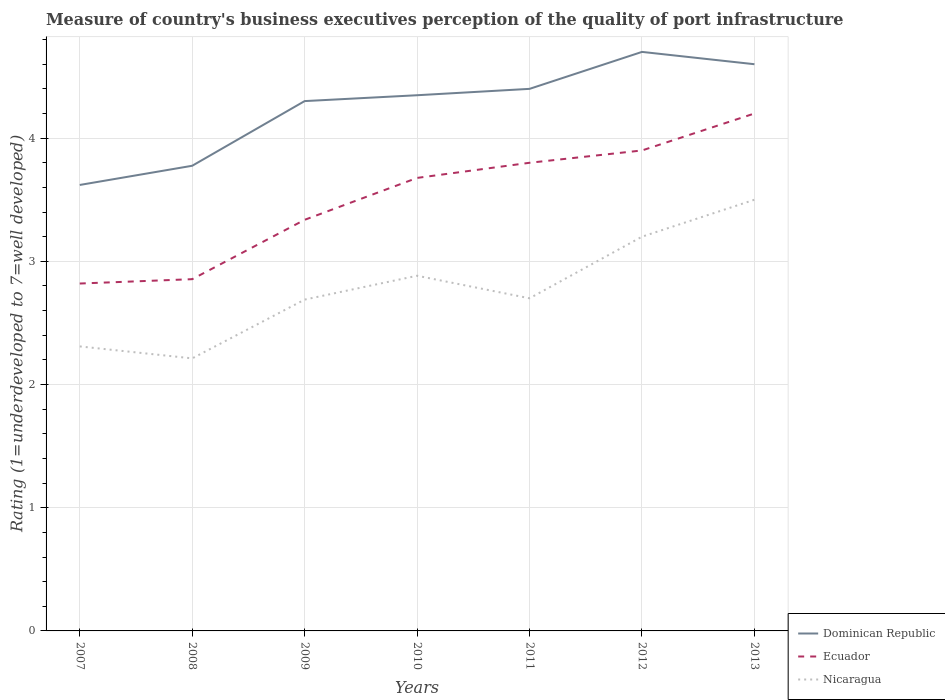How many different coloured lines are there?
Offer a terse response. 3. Does the line corresponding to Nicaragua intersect with the line corresponding to Dominican Republic?
Provide a short and direct response. No. Is the number of lines equal to the number of legend labels?
Provide a short and direct response. Yes. Across all years, what is the maximum ratings of the quality of port infrastructure in Ecuador?
Offer a very short reply. 2.82. In which year was the ratings of the quality of port infrastructure in Nicaragua maximum?
Your answer should be compact. 2008. What is the total ratings of the quality of port infrastructure in Ecuador in the graph?
Offer a terse response. -1.08. What is the difference between the highest and the second highest ratings of the quality of port infrastructure in Nicaragua?
Provide a succinct answer. 1.29. What is the difference between the highest and the lowest ratings of the quality of port infrastructure in Ecuador?
Offer a terse response. 4. Is the ratings of the quality of port infrastructure in Nicaragua strictly greater than the ratings of the quality of port infrastructure in Ecuador over the years?
Your response must be concise. Yes. How many lines are there?
Your answer should be compact. 3. How many years are there in the graph?
Keep it short and to the point. 7. What is the difference between two consecutive major ticks on the Y-axis?
Keep it short and to the point. 1. Are the values on the major ticks of Y-axis written in scientific E-notation?
Provide a succinct answer. No. How many legend labels are there?
Offer a terse response. 3. What is the title of the graph?
Your response must be concise. Measure of country's business executives perception of the quality of port infrastructure. What is the label or title of the Y-axis?
Provide a succinct answer. Rating (1=underdeveloped to 7=well developed). What is the Rating (1=underdeveloped to 7=well developed) of Dominican Republic in 2007?
Make the answer very short. 3.62. What is the Rating (1=underdeveloped to 7=well developed) of Ecuador in 2007?
Provide a succinct answer. 2.82. What is the Rating (1=underdeveloped to 7=well developed) in Nicaragua in 2007?
Your answer should be compact. 2.31. What is the Rating (1=underdeveloped to 7=well developed) of Dominican Republic in 2008?
Provide a succinct answer. 3.78. What is the Rating (1=underdeveloped to 7=well developed) in Ecuador in 2008?
Provide a succinct answer. 2.86. What is the Rating (1=underdeveloped to 7=well developed) in Nicaragua in 2008?
Your answer should be very brief. 2.21. What is the Rating (1=underdeveloped to 7=well developed) in Dominican Republic in 2009?
Keep it short and to the point. 4.3. What is the Rating (1=underdeveloped to 7=well developed) in Ecuador in 2009?
Keep it short and to the point. 3.34. What is the Rating (1=underdeveloped to 7=well developed) in Nicaragua in 2009?
Give a very brief answer. 2.69. What is the Rating (1=underdeveloped to 7=well developed) in Dominican Republic in 2010?
Your response must be concise. 4.35. What is the Rating (1=underdeveloped to 7=well developed) of Ecuador in 2010?
Provide a succinct answer. 3.68. What is the Rating (1=underdeveloped to 7=well developed) of Nicaragua in 2010?
Offer a terse response. 2.88. What is the Rating (1=underdeveloped to 7=well developed) of Nicaragua in 2011?
Ensure brevity in your answer.  2.7. What is the Rating (1=underdeveloped to 7=well developed) of Ecuador in 2012?
Offer a very short reply. 3.9. What is the Rating (1=underdeveloped to 7=well developed) in Dominican Republic in 2013?
Your answer should be very brief. 4.6. What is the Rating (1=underdeveloped to 7=well developed) of Nicaragua in 2013?
Your answer should be very brief. 3.5. Across all years, what is the maximum Rating (1=underdeveloped to 7=well developed) in Nicaragua?
Ensure brevity in your answer.  3.5. Across all years, what is the minimum Rating (1=underdeveloped to 7=well developed) of Dominican Republic?
Offer a terse response. 3.62. Across all years, what is the minimum Rating (1=underdeveloped to 7=well developed) of Ecuador?
Your response must be concise. 2.82. Across all years, what is the minimum Rating (1=underdeveloped to 7=well developed) in Nicaragua?
Ensure brevity in your answer.  2.21. What is the total Rating (1=underdeveloped to 7=well developed) in Dominican Republic in the graph?
Your answer should be very brief. 29.74. What is the total Rating (1=underdeveloped to 7=well developed) in Ecuador in the graph?
Give a very brief answer. 24.59. What is the total Rating (1=underdeveloped to 7=well developed) of Nicaragua in the graph?
Give a very brief answer. 19.49. What is the difference between the Rating (1=underdeveloped to 7=well developed) in Dominican Republic in 2007 and that in 2008?
Provide a succinct answer. -0.16. What is the difference between the Rating (1=underdeveloped to 7=well developed) in Ecuador in 2007 and that in 2008?
Your answer should be compact. -0.04. What is the difference between the Rating (1=underdeveloped to 7=well developed) of Nicaragua in 2007 and that in 2008?
Provide a short and direct response. 0.1. What is the difference between the Rating (1=underdeveloped to 7=well developed) of Dominican Republic in 2007 and that in 2009?
Offer a terse response. -0.68. What is the difference between the Rating (1=underdeveloped to 7=well developed) of Ecuador in 2007 and that in 2009?
Your response must be concise. -0.52. What is the difference between the Rating (1=underdeveloped to 7=well developed) of Nicaragua in 2007 and that in 2009?
Keep it short and to the point. -0.38. What is the difference between the Rating (1=underdeveloped to 7=well developed) in Dominican Republic in 2007 and that in 2010?
Provide a short and direct response. -0.73. What is the difference between the Rating (1=underdeveloped to 7=well developed) of Ecuador in 2007 and that in 2010?
Keep it short and to the point. -0.86. What is the difference between the Rating (1=underdeveloped to 7=well developed) in Nicaragua in 2007 and that in 2010?
Your answer should be very brief. -0.57. What is the difference between the Rating (1=underdeveloped to 7=well developed) of Dominican Republic in 2007 and that in 2011?
Make the answer very short. -0.78. What is the difference between the Rating (1=underdeveloped to 7=well developed) of Ecuador in 2007 and that in 2011?
Keep it short and to the point. -0.98. What is the difference between the Rating (1=underdeveloped to 7=well developed) in Nicaragua in 2007 and that in 2011?
Provide a short and direct response. -0.39. What is the difference between the Rating (1=underdeveloped to 7=well developed) in Dominican Republic in 2007 and that in 2012?
Keep it short and to the point. -1.08. What is the difference between the Rating (1=underdeveloped to 7=well developed) of Ecuador in 2007 and that in 2012?
Your answer should be very brief. -1.08. What is the difference between the Rating (1=underdeveloped to 7=well developed) of Nicaragua in 2007 and that in 2012?
Your answer should be compact. -0.89. What is the difference between the Rating (1=underdeveloped to 7=well developed) of Dominican Republic in 2007 and that in 2013?
Make the answer very short. -0.98. What is the difference between the Rating (1=underdeveloped to 7=well developed) in Ecuador in 2007 and that in 2013?
Your answer should be compact. -1.38. What is the difference between the Rating (1=underdeveloped to 7=well developed) of Nicaragua in 2007 and that in 2013?
Your response must be concise. -1.19. What is the difference between the Rating (1=underdeveloped to 7=well developed) in Dominican Republic in 2008 and that in 2009?
Keep it short and to the point. -0.53. What is the difference between the Rating (1=underdeveloped to 7=well developed) of Ecuador in 2008 and that in 2009?
Your answer should be compact. -0.48. What is the difference between the Rating (1=underdeveloped to 7=well developed) of Nicaragua in 2008 and that in 2009?
Keep it short and to the point. -0.48. What is the difference between the Rating (1=underdeveloped to 7=well developed) in Dominican Republic in 2008 and that in 2010?
Your response must be concise. -0.57. What is the difference between the Rating (1=underdeveloped to 7=well developed) of Ecuador in 2008 and that in 2010?
Your answer should be compact. -0.82. What is the difference between the Rating (1=underdeveloped to 7=well developed) of Nicaragua in 2008 and that in 2010?
Keep it short and to the point. -0.67. What is the difference between the Rating (1=underdeveloped to 7=well developed) of Dominican Republic in 2008 and that in 2011?
Provide a succinct answer. -0.62. What is the difference between the Rating (1=underdeveloped to 7=well developed) in Ecuador in 2008 and that in 2011?
Your response must be concise. -0.94. What is the difference between the Rating (1=underdeveloped to 7=well developed) of Nicaragua in 2008 and that in 2011?
Your response must be concise. -0.49. What is the difference between the Rating (1=underdeveloped to 7=well developed) in Dominican Republic in 2008 and that in 2012?
Ensure brevity in your answer.  -0.92. What is the difference between the Rating (1=underdeveloped to 7=well developed) of Ecuador in 2008 and that in 2012?
Your response must be concise. -1.04. What is the difference between the Rating (1=underdeveloped to 7=well developed) in Nicaragua in 2008 and that in 2012?
Offer a terse response. -0.99. What is the difference between the Rating (1=underdeveloped to 7=well developed) of Dominican Republic in 2008 and that in 2013?
Your response must be concise. -0.82. What is the difference between the Rating (1=underdeveloped to 7=well developed) of Ecuador in 2008 and that in 2013?
Offer a terse response. -1.34. What is the difference between the Rating (1=underdeveloped to 7=well developed) in Nicaragua in 2008 and that in 2013?
Offer a very short reply. -1.29. What is the difference between the Rating (1=underdeveloped to 7=well developed) in Dominican Republic in 2009 and that in 2010?
Provide a short and direct response. -0.05. What is the difference between the Rating (1=underdeveloped to 7=well developed) of Ecuador in 2009 and that in 2010?
Make the answer very short. -0.34. What is the difference between the Rating (1=underdeveloped to 7=well developed) in Nicaragua in 2009 and that in 2010?
Provide a short and direct response. -0.19. What is the difference between the Rating (1=underdeveloped to 7=well developed) in Dominican Republic in 2009 and that in 2011?
Your answer should be very brief. -0.1. What is the difference between the Rating (1=underdeveloped to 7=well developed) in Ecuador in 2009 and that in 2011?
Your response must be concise. -0.46. What is the difference between the Rating (1=underdeveloped to 7=well developed) of Nicaragua in 2009 and that in 2011?
Provide a succinct answer. -0.01. What is the difference between the Rating (1=underdeveloped to 7=well developed) of Dominican Republic in 2009 and that in 2012?
Make the answer very short. -0.4. What is the difference between the Rating (1=underdeveloped to 7=well developed) in Ecuador in 2009 and that in 2012?
Give a very brief answer. -0.56. What is the difference between the Rating (1=underdeveloped to 7=well developed) of Nicaragua in 2009 and that in 2012?
Provide a short and direct response. -0.51. What is the difference between the Rating (1=underdeveloped to 7=well developed) in Dominican Republic in 2009 and that in 2013?
Ensure brevity in your answer.  -0.3. What is the difference between the Rating (1=underdeveloped to 7=well developed) in Ecuador in 2009 and that in 2013?
Keep it short and to the point. -0.86. What is the difference between the Rating (1=underdeveloped to 7=well developed) of Nicaragua in 2009 and that in 2013?
Keep it short and to the point. -0.81. What is the difference between the Rating (1=underdeveloped to 7=well developed) of Dominican Republic in 2010 and that in 2011?
Your answer should be very brief. -0.05. What is the difference between the Rating (1=underdeveloped to 7=well developed) of Ecuador in 2010 and that in 2011?
Your answer should be compact. -0.12. What is the difference between the Rating (1=underdeveloped to 7=well developed) of Nicaragua in 2010 and that in 2011?
Provide a succinct answer. 0.18. What is the difference between the Rating (1=underdeveloped to 7=well developed) in Dominican Republic in 2010 and that in 2012?
Your answer should be very brief. -0.35. What is the difference between the Rating (1=underdeveloped to 7=well developed) in Ecuador in 2010 and that in 2012?
Your response must be concise. -0.22. What is the difference between the Rating (1=underdeveloped to 7=well developed) of Nicaragua in 2010 and that in 2012?
Ensure brevity in your answer.  -0.32. What is the difference between the Rating (1=underdeveloped to 7=well developed) in Dominican Republic in 2010 and that in 2013?
Your answer should be very brief. -0.25. What is the difference between the Rating (1=underdeveloped to 7=well developed) of Ecuador in 2010 and that in 2013?
Your answer should be very brief. -0.52. What is the difference between the Rating (1=underdeveloped to 7=well developed) in Nicaragua in 2010 and that in 2013?
Make the answer very short. -0.62. What is the difference between the Rating (1=underdeveloped to 7=well developed) in Dominican Republic in 2011 and that in 2013?
Provide a succinct answer. -0.2. What is the difference between the Rating (1=underdeveloped to 7=well developed) in Ecuador in 2011 and that in 2013?
Make the answer very short. -0.4. What is the difference between the Rating (1=underdeveloped to 7=well developed) in Dominican Republic in 2012 and that in 2013?
Offer a terse response. 0.1. What is the difference between the Rating (1=underdeveloped to 7=well developed) in Dominican Republic in 2007 and the Rating (1=underdeveloped to 7=well developed) in Ecuador in 2008?
Your answer should be compact. 0.76. What is the difference between the Rating (1=underdeveloped to 7=well developed) in Dominican Republic in 2007 and the Rating (1=underdeveloped to 7=well developed) in Nicaragua in 2008?
Offer a terse response. 1.41. What is the difference between the Rating (1=underdeveloped to 7=well developed) of Ecuador in 2007 and the Rating (1=underdeveloped to 7=well developed) of Nicaragua in 2008?
Give a very brief answer. 0.61. What is the difference between the Rating (1=underdeveloped to 7=well developed) in Dominican Republic in 2007 and the Rating (1=underdeveloped to 7=well developed) in Ecuador in 2009?
Make the answer very short. 0.28. What is the difference between the Rating (1=underdeveloped to 7=well developed) in Dominican Republic in 2007 and the Rating (1=underdeveloped to 7=well developed) in Nicaragua in 2009?
Offer a terse response. 0.93. What is the difference between the Rating (1=underdeveloped to 7=well developed) of Ecuador in 2007 and the Rating (1=underdeveloped to 7=well developed) of Nicaragua in 2009?
Ensure brevity in your answer.  0.13. What is the difference between the Rating (1=underdeveloped to 7=well developed) of Dominican Republic in 2007 and the Rating (1=underdeveloped to 7=well developed) of Ecuador in 2010?
Your response must be concise. -0.06. What is the difference between the Rating (1=underdeveloped to 7=well developed) in Dominican Republic in 2007 and the Rating (1=underdeveloped to 7=well developed) in Nicaragua in 2010?
Ensure brevity in your answer.  0.74. What is the difference between the Rating (1=underdeveloped to 7=well developed) of Ecuador in 2007 and the Rating (1=underdeveloped to 7=well developed) of Nicaragua in 2010?
Your answer should be very brief. -0.06. What is the difference between the Rating (1=underdeveloped to 7=well developed) of Dominican Republic in 2007 and the Rating (1=underdeveloped to 7=well developed) of Ecuador in 2011?
Provide a succinct answer. -0.18. What is the difference between the Rating (1=underdeveloped to 7=well developed) of Dominican Republic in 2007 and the Rating (1=underdeveloped to 7=well developed) of Nicaragua in 2011?
Make the answer very short. 0.92. What is the difference between the Rating (1=underdeveloped to 7=well developed) of Ecuador in 2007 and the Rating (1=underdeveloped to 7=well developed) of Nicaragua in 2011?
Your answer should be very brief. 0.12. What is the difference between the Rating (1=underdeveloped to 7=well developed) in Dominican Republic in 2007 and the Rating (1=underdeveloped to 7=well developed) in Ecuador in 2012?
Ensure brevity in your answer.  -0.28. What is the difference between the Rating (1=underdeveloped to 7=well developed) in Dominican Republic in 2007 and the Rating (1=underdeveloped to 7=well developed) in Nicaragua in 2012?
Offer a very short reply. 0.42. What is the difference between the Rating (1=underdeveloped to 7=well developed) in Ecuador in 2007 and the Rating (1=underdeveloped to 7=well developed) in Nicaragua in 2012?
Offer a terse response. -0.38. What is the difference between the Rating (1=underdeveloped to 7=well developed) in Dominican Republic in 2007 and the Rating (1=underdeveloped to 7=well developed) in Ecuador in 2013?
Provide a short and direct response. -0.58. What is the difference between the Rating (1=underdeveloped to 7=well developed) in Dominican Republic in 2007 and the Rating (1=underdeveloped to 7=well developed) in Nicaragua in 2013?
Your answer should be very brief. 0.12. What is the difference between the Rating (1=underdeveloped to 7=well developed) in Ecuador in 2007 and the Rating (1=underdeveloped to 7=well developed) in Nicaragua in 2013?
Your answer should be very brief. -0.68. What is the difference between the Rating (1=underdeveloped to 7=well developed) of Dominican Republic in 2008 and the Rating (1=underdeveloped to 7=well developed) of Ecuador in 2009?
Your response must be concise. 0.44. What is the difference between the Rating (1=underdeveloped to 7=well developed) of Dominican Republic in 2008 and the Rating (1=underdeveloped to 7=well developed) of Nicaragua in 2009?
Ensure brevity in your answer.  1.09. What is the difference between the Rating (1=underdeveloped to 7=well developed) in Ecuador in 2008 and the Rating (1=underdeveloped to 7=well developed) in Nicaragua in 2009?
Provide a short and direct response. 0.17. What is the difference between the Rating (1=underdeveloped to 7=well developed) in Dominican Republic in 2008 and the Rating (1=underdeveloped to 7=well developed) in Ecuador in 2010?
Your answer should be very brief. 0.1. What is the difference between the Rating (1=underdeveloped to 7=well developed) of Dominican Republic in 2008 and the Rating (1=underdeveloped to 7=well developed) of Nicaragua in 2010?
Keep it short and to the point. 0.89. What is the difference between the Rating (1=underdeveloped to 7=well developed) of Ecuador in 2008 and the Rating (1=underdeveloped to 7=well developed) of Nicaragua in 2010?
Offer a very short reply. -0.03. What is the difference between the Rating (1=underdeveloped to 7=well developed) in Dominican Republic in 2008 and the Rating (1=underdeveloped to 7=well developed) in Ecuador in 2011?
Your answer should be very brief. -0.02. What is the difference between the Rating (1=underdeveloped to 7=well developed) of Dominican Republic in 2008 and the Rating (1=underdeveloped to 7=well developed) of Nicaragua in 2011?
Provide a succinct answer. 1.08. What is the difference between the Rating (1=underdeveloped to 7=well developed) in Ecuador in 2008 and the Rating (1=underdeveloped to 7=well developed) in Nicaragua in 2011?
Your answer should be very brief. 0.16. What is the difference between the Rating (1=underdeveloped to 7=well developed) of Dominican Republic in 2008 and the Rating (1=underdeveloped to 7=well developed) of Ecuador in 2012?
Keep it short and to the point. -0.12. What is the difference between the Rating (1=underdeveloped to 7=well developed) in Dominican Republic in 2008 and the Rating (1=underdeveloped to 7=well developed) in Nicaragua in 2012?
Ensure brevity in your answer.  0.58. What is the difference between the Rating (1=underdeveloped to 7=well developed) in Ecuador in 2008 and the Rating (1=underdeveloped to 7=well developed) in Nicaragua in 2012?
Your response must be concise. -0.34. What is the difference between the Rating (1=underdeveloped to 7=well developed) of Dominican Republic in 2008 and the Rating (1=underdeveloped to 7=well developed) of Ecuador in 2013?
Your response must be concise. -0.42. What is the difference between the Rating (1=underdeveloped to 7=well developed) of Dominican Republic in 2008 and the Rating (1=underdeveloped to 7=well developed) of Nicaragua in 2013?
Provide a short and direct response. 0.28. What is the difference between the Rating (1=underdeveloped to 7=well developed) in Ecuador in 2008 and the Rating (1=underdeveloped to 7=well developed) in Nicaragua in 2013?
Provide a short and direct response. -0.64. What is the difference between the Rating (1=underdeveloped to 7=well developed) in Dominican Republic in 2009 and the Rating (1=underdeveloped to 7=well developed) in Ecuador in 2010?
Keep it short and to the point. 0.62. What is the difference between the Rating (1=underdeveloped to 7=well developed) in Dominican Republic in 2009 and the Rating (1=underdeveloped to 7=well developed) in Nicaragua in 2010?
Offer a terse response. 1.42. What is the difference between the Rating (1=underdeveloped to 7=well developed) in Ecuador in 2009 and the Rating (1=underdeveloped to 7=well developed) in Nicaragua in 2010?
Make the answer very short. 0.45. What is the difference between the Rating (1=underdeveloped to 7=well developed) in Dominican Republic in 2009 and the Rating (1=underdeveloped to 7=well developed) in Ecuador in 2011?
Provide a succinct answer. 0.5. What is the difference between the Rating (1=underdeveloped to 7=well developed) in Dominican Republic in 2009 and the Rating (1=underdeveloped to 7=well developed) in Nicaragua in 2011?
Your response must be concise. 1.6. What is the difference between the Rating (1=underdeveloped to 7=well developed) in Ecuador in 2009 and the Rating (1=underdeveloped to 7=well developed) in Nicaragua in 2011?
Ensure brevity in your answer.  0.64. What is the difference between the Rating (1=underdeveloped to 7=well developed) of Dominican Republic in 2009 and the Rating (1=underdeveloped to 7=well developed) of Ecuador in 2012?
Your answer should be compact. 0.4. What is the difference between the Rating (1=underdeveloped to 7=well developed) of Dominican Republic in 2009 and the Rating (1=underdeveloped to 7=well developed) of Nicaragua in 2012?
Provide a short and direct response. 1.1. What is the difference between the Rating (1=underdeveloped to 7=well developed) of Ecuador in 2009 and the Rating (1=underdeveloped to 7=well developed) of Nicaragua in 2012?
Give a very brief answer. 0.14. What is the difference between the Rating (1=underdeveloped to 7=well developed) of Dominican Republic in 2009 and the Rating (1=underdeveloped to 7=well developed) of Ecuador in 2013?
Keep it short and to the point. 0.1. What is the difference between the Rating (1=underdeveloped to 7=well developed) of Dominican Republic in 2009 and the Rating (1=underdeveloped to 7=well developed) of Nicaragua in 2013?
Your answer should be very brief. 0.8. What is the difference between the Rating (1=underdeveloped to 7=well developed) in Ecuador in 2009 and the Rating (1=underdeveloped to 7=well developed) in Nicaragua in 2013?
Offer a terse response. -0.16. What is the difference between the Rating (1=underdeveloped to 7=well developed) in Dominican Republic in 2010 and the Rating (1=underdeveloped to 7=well developed) in Ecuador in 2011?
Offer a terse response. 0.55. What is the difference between the Rating (1=underdeveloped to 7=well developed) of Dominican Republic in 2010 and the Rating (1=underdeveloped to 7=well developed) of Nicaragua in 2011?
Keep it short and to the point. 1.65. What is the difference between the Rating (1=underdeveloped to 7=well developed) of Ecuador in 2010 and the Rating (1=underdeveloped to 7=well developed) of Nicaragua in 2011?
Give a very brief answer. 0.98. What is the difference between the Rating (1=underdeveloped to 7=well developed) of Dominican Republic in 2010 and the Rating (1=underdeveloped to 7=well developed) of Ecuador in 2012?
Offer a terse response. 0.45. What is the difference between the Rating (1=underdeveloped to 7=well developed) in Dominican Republic in 2010 and the Rating (1=underdeveloped to 7=well developed) in Nicaragua in 2012?
Give a very brief answer. 1.15. What is the difference between the Rating (1=underdeveloped to 7=well developed) of Ecuador in 2010 and the Rating (1=underdeveloped to 7=well developed) of Nicaragua in 2012?
Offer a terse response. 0.48. What is the difference between the Rating (1=underdeveloped to 7=well developed) of Dominican Republic in 2010 and the Rating (1=underdeveloped to 7=well developed) of Ecuador in 2013?
Provide a succinct answer. 0.15. What is the difference between the Rating (1=underdeveloped to 7=well developed) of Dominican Republic in 2010 and the Rating (1=underdeveloped to 7=well developed) of Nicaragua in 2013?
Make the answer very short. 0.85. What is the difference between the Rating (1=underdeveloped to 7=well developed) in Ecuador in 2010 and the Rating (1=underdeveloped to 7=well developed) in Nicaragua in 2013?
Keep it short and to the point. 0.18. What is the difference between the Rating (1=underdeveloped to 7=well developed) of Dominican Republic in 2011 and the Rating (1=underdeveloped to 7=well developed) of Ecuador in 2012?
Ensure brevity in your answer.  0.5. What is the difference between the Rating (1=underdeveloped to 7=well developed) in Dominican Republic in 2012 and the Rating (1=underdeveloped to 7=well developed) in Ecuador in 2013?
Offer a very short reply. 0.5. What is the difference between the Rating (1=underdeveloped to 7=well developed) of Ecuador in 2012 and the Rating (1=underdeveloped to 7=well developed) of Nicaragua in 2013?
Your answer should be compact. 0.4. What is the average Rating (1=underdeveloped to 7=well developed) in Dominican Republic per year?
Your answer should be very brief. 4.25. What is the average Rating (1=underdeveloped to 7=well developed) of Ecuador per year?
Make the answer very short. 3.51. What is the average Rating (1=underdeveloped to 7=well developed) in Nicaragua per year?
Your answer should be compact. 2.78. In the year 2007, what is the difference between the Rating (1=underdeveloped to 7=well developed) of Dominican Republic and Rating (1=underdeveloped to 7=well developed) of Ecuador?
Keep it short and to the point. 0.8. In the year 2007, what is the difference between the Rating (1=underdeveloped to 7=well developed) of Dominican Republic and Rating (1=underdeveloped to 7=well developed) of Nicaragua?
Provide a short and direct response. 1.31. In the year 2007, what is the difference between the Rating (1=underdeveloped to 7=well developed) of Ecuador and Rating (1=underdeveloped to 7=well developed) of Nicaragua?
Ensure brevity in your answer.  0.51. In the year 2008, what is the difference between the Rating (1=underdeveloped to 7=well developed) of Dominican Republic and Rating (1=underdeveloped to 7=well developed) of Ecuador?
Ensure brevity in your answer.  0.92. In the year 2008, what is the difference between the Rating (1=underdeveloped to 7=well developed) in Dominican Republic and Rating (1=underdeveloped to 7=well developed) in Nicaragua?
Offer a terse response. 1.56. In the year 2008, what is the difference between the Rating (1=underdeveloped to 7=well developed) in Ecuador and Rating (1=underdeveloped to 7=well developed) in Nicaragua?
Ensure brevity in your answer.  0.64. In the year 2009, what is the difference between the Rating (1=underdeveloped to 7=well developed) in Dominican Republic and Rating (1=underdeveloped to 7=well developed) in Ecuador?
Your answer should be very brief. 0.96. In the year 2009, what is the difference between the Rating (1=underdeveloped to 7=well developed) of Dominican Republic and Rating (1=underdeveloped to 7=well developed) of Nicaragua?
Keep it short and to the point. 1.61. In the year 2009, what is the difference between the Rating (1=underdeveloped to 7=well developed) of Ecuador and Rating (1=underdeveloped to 7=well developed) of Nicaragua?
Make the answer very short. 0.65. In the year 2010, what is the difference between the Rating (1=underdeveloped to 7=well developed) of Dominican Republic and Rating (1=underdeveloped to 7=well developed) of Ecuador?
Your response must be concise. 0.67. In the year 2010, what is the difference between the Rating (1=underdeveloped to 7=well developed) in Dominican Republic and Rating (1=underdeveloped to 7=well developed) in Nicaragua?
Ensure brevity in your answer.  1.47. In the year 2010, what is the difference between the Rating (1=underdeveloped to 7=well developed) of Ecuador and Rating (1=underdeveloped to 7=well developed) of Nicaragua?
Ensure brevity in your answer.  0.79. In the year 2011, what is the difference between the Rating (1=underdeveloped to 7=well developed) of Dominican Republic and Rating (1=underdeveloped to 7=well developed) of Ecuador?
Keep it short and to the point. 0.6. In the year 2012, what is the difference between the Rating (1=underdeveloped to 7=well developed) in Dominican Republic and Rating (1=underdeveloped to 7=well developed) in Ecuador?
Ensure brevity in your answer.  0.8. In the year 2012, what is the difference between the Rating (1=underdeveloped to 7=well developed) of Dominican Republic and Rating (1=underdeveloped to 7=well developed) of Nicaragua?
Your answer should be compact. 1.5. In the year 2012, what is the difference between the Rating (1=underdeveloped to 7=well developed) of Ecuador and Rating (1=underdeveloped to 7=well developed) of Nicaragua?
Your response must be concise. 0.7. In the year 2013, what is the difference between the Rating (1=underdeveloped to 7=well developed) in Ecuador and Rating (1=underdeveloped to 7=well developed) in Nicaragua?
Make the answer very short. 0.7. What is the ratio of the Rating (1=underdeveloped to 7=well developed) of Dominican Republic in 2007 to that in 2008?
Your response must be concise. 0.96. What is the ratio of the Rating (1=underdeveloped to 7=well developed) in Ecuador in 2007 to that in 2008?
Give a very brief answer. 0.99. What is the ratio of the Rating (1=underdeveloped to 7=well developed) in Nicaragua in 2007 to that in 2008?
Ensure brevity in your answer.  1.04. What is the ratio of the Rating (1=underdeveloped to 7=well developed) in Dominican Republic in 2007 to that in 2009?
Make the answer very short. 0.84. What is the ratio of the Rating (1=underdeveloped to 7=well developed) of Ecuador in 2007 to that in 2009?
Make the answer very short. 0.84. What is the ratio of the Rating (1=underdeveloped to 7=well developed) of Nicaragua in 2007 to that in 2009?
Offer a terse response. 0.86. What is the ratio of the Rating (1=underdeveloped to 7=well developed) of Dominican Republic in 2007 to that in 2010?
Offer a very short reply. 0.83. What is the ratio of the Rating (1=underdeveloped to 7=well developed) of Ecuador in 2007 to that in 2010?
Your answer should be compact. 0.77. What is the ratio of the Rating (1=underdeveloped to 7=well developed) in Nicaragua in 2007 to that in 2010?
Your response must be concise. 0.8. What is the ratio of the Rating (1=underdeveloped to 7=well developed) of Dominican Republic in 2007 to that in 2011?
Your answer should be very brief. 0.82. What is the ratio of the Rating (1=underdeveloped to 7=well developed) in Ecuador in 2007 to that in 2011?
Offer a terse response. 0.74. What is the ratio of the Rating (1=underdeveloped to 7=well developed) in Nicaragua in 2007 to that in 2011?
Your answer should be very brief. 0.86. What is the ratio of the Rating (1=underdeveloped to 7=well developed) in Dominican Republic in 2007 to that in 2012?
Your response must be concise. 0.77. What is the ratio of the Rating (1=underdeveloped to 7=well developed) in Ecuador in 2007 to that in 2012?
Offer a very short reply. 0.72. What is the ratio of the Rating (1=underdeveloped to 7=well developed) of Nicaragua in 2007 to that in 2012?
Offer a terse response. 0.72. What is the ratio of the Rating (1=underdeveloped to 7=well developed) of Dominican Republic in 2007 to that in 2013?
Keep it short and to the point. 0.79. What is the ratio of the Rating (1=underdeveloped to 7=well developed) of Ecuador in 2007 to that in 2013?
Make the answer very short. 0.67. What is the ratio of the Rating (1=underdeveloped to 7=well developed) in Nicaragua in 2007 to that in 2013?
Your answer should be compact. 0.66. What is the ratio of the Rating (1=underdeveloped to 7=well developed) in Dominican Republic in 2008 to that in 2009?
Offer a terse response. 0.88. What is the ratio of the Rating (1=underdeveloped to 7=well developed) in Ecuador in 2008 to that in 2009?
Provide a short and direct response. 0.86. What is the ratio of the Rating (1=underdeveloped to 7=well developed) in Nicaragua in 2008 to that in 2009?
Offer a terse response. 0.82. What is the ratio of the Rating (1=underdeveloped to 7=well developed) in Dominican Republic in 2008 to that in 2010?
Ensure brevity in your answer.  0.87. What is the ratio of the Rating (1=underdeveloped to 7=well developed) in Ecuador in 2008 to that in 2010?
Your response must be concise. 0.78. What is the ratio of the Rating (1=underdeveloped to 7=well developed) of Nicaragua in 2008 to that in 2010?
Your answer should be very brief. 0.77. What is the ratio of the Rating (1=underdeveloped to 7=well developed) of Dominican Republic in 2008 to that in 2011?
Your answer should be very brief. 0.86. What is the ratio of the Rating (1=underdeveloped to 7=well developed) of Ecuador in 2008 to that in 2011?
Offer a terse response. 0.75. What is the ratio of the Rating (1=underdeveloped to 7=well developed) in Nicaragua in 2008 to that in 2011?
Ensure brevity in your answer.  0.82. What is the ratio of the Rating (1=underdeveloped to 7=well developed) in Dominican Republic in 2008 to that in 2012?
Your response must be concise. 0.8. What is the ratio of the Rating (1=underdeveloped to 7=well developed) in Ecuador in 2008 to that in 2012?
Make the answer very short. 0.73. What is the ratio of the Rating (1=underdeveloped to 7=well developed) of Nicaragua in 2008 to that in 2012?
Make the answer very short. 0.69. What is the ratio of the Rating (1=underdeveloped to 7=well developed) in Dominican Republic in 2008 to that in 2013?
Your answer should be very brief. 0.82. What is the ratio of the Rating (1=underdeveloped to 7=well developed) in Ecuador in 2008 to that in 2013?
Offer a terse response. 0.68. What is the ratio of the Rating (1=underdeveloped to 7=well developed) of Nicaragua in 2008 to that in 2013?
Offer a very short reply. 0.63. What is the ratio of the Rating (1=underdeveloped to 7=well developed) of Ecuador in 2009 to that in 2010?
Your answer should be compact. 0.91. What is the ratio of the Rating (1=underdeveloped to 7=well developed) of Nicaragua in 2009 to that in 2010?
Provide a succinct answer. 0.93. What is the ratio of the Rating (1=underdeveloped to 7=well developed) of Dominican Republic in 2009 to that in 2011?
Provide a short and direct response. 0.98. What is the ratio of the Rating (1=underdeveloped to 7=well developed) of Ecuador in 2009 to that in 2011?
Make the answer very short. 0.88. What is the ratio of the Rating (1=underdeveloped to 7=well developed) in Nicaragua in 2009 to that in 2011?
Your answer should be very brief. 1. What is the ratio of the Rating (1=underdeveloped to 7=well developed) in Dominican Republic in 2009 to that in 2012?
Provide a succinct answer. 0.92. What is the ratio of the Rating (1=underdeveloped to 7=well developed) of Ecuador in 2009 to that in 2012?
Give a very brief answer. 0.86. What is the ratio of the Rating (1=underdeveloped to 7=well developed) in Nicaragua in 2009 to that in 2012?
Offer a very short reply. 0.84. What is the ratio of the Rating (1=underdeveloped to 7=well developed) in Dominican Republic in 2009 to that in 2013?
Offer a terse response. 0.93. What is the ratio of the Rating (1=underdeveloped to 7=well developed) of Ecuador in 2009 to that in 2013?
Give a very brief answer. 0.79. What is the ratio of the Rating (1=underdeveloped to 7=well developed) of Nicaragua in 2009 to that in 2013?
Offer a very short reply. 0.77. What is the ratio of the Rating (1=underdeveloped to 7=well developed) in Ecuador in 2010 to that in 2011?
Keep it short and to the point. 0.97. What is the ratio of the Rating (1=underdeveloped to 7=well developed) of Nicaragua in 2010 to that in 2011?
Your answer should be compact. 1.07. What is the ratio of the Rating (1=underdeveloped to 7=well developed) in Dominican Republic in 2010 to that in 2012?
Make the answer very short. 0.93. What is the ratio of the Rating (1=underdeveloped to 7=well developed) of Ecuador in 2010 to that in 2012?
Provide a short and direct response. 0.94. What is the ratio of the Rating (1=underdeveloped to 7=well developed) of Nicaragua in 2010 to that in 2012?
Your response must be concise. 0.9. What is the ratio of the Rating (1=underdeveloped to 7=well developed) of Dominican Republic in 2010 to that in 2013?
Ensure brevity in your answer.  0.95. What is the ratio of the Rating (1=underdeveloped to 7=well developed) in Ecuador in 2010 to that in 2013?
Provide a short and direct response. 0.88. What is the ratio of the Rating (1=underdeveloped to 7=well developed) of Nicaragua in 2010 to that in 2013?
Offer a very short reply. 0.82. What is the ratio of the Rating (1=underdeveloped to 7=well developed) of Dominican Republic in 2011 to that in 2012?
Provide a short and direct response. 0.94. What is the ratio of the Rating (1=underdeveloped to 7=well developed) in Ecuador in 2011 to that in 2012?
Your answer should be very brief. 0.97. What is the ratio of the Rating (1=underdeveloped to 7=well developed) in Nicaragua in 2011 to that in 2012?
Provide a succinct answer. 0.84. What is the ratio of the Rating (1=underdeveloped to 7=well developed) of Dominican Republic in 2011 to that in 2013?
Provide a short and direct response. 0.96. What is the ratio of the Rating (1=underdeveloped to 7=well developed) of Ecuador in 2011 to that in 2013?
Make the answer very short. 0.9. What is the ratio of the Rating (1=underdeveloped to 7=well developed) of Nicaragua in 2011 to that in 2013?
Provide a succinct answer. 0.77. What is the ratio of the Rating (1=underdeveloped to 7=well developed) of Dominican Republic in 2012 to that in 2013?
Make the answer very short. 1.02. What is the ratio of the Rating (1=underdeveloped to 7=well developed) in Nicaragua in 2012 to that in 2013?
Your response must be concise. 0.91. What is the difference between the highest and the second highest Rating (1=underdeveloped to 7=well developed) in Dominican Republic?
Your response must be concise. 0.1. What is the difference between the highest and the second highest Rating (1=underdeveloped to 7=well developed) of Ecuador?
Provide a succinct answer. 0.3. What is the difference between the highest and the lowest Rating (1=underdeveloped to 7=well developed) in Dominican Republic?
Your answer should be compact. 1.08. What is the difference between the highest and the lowest Rating (1=underdeveloped to 7=well developed) in Ecuador?
Give a very brief answer. 1.38. What is the difference between the highest and the lowest Rating (1=underdeveloped to 7=well developed) of Nicaragua?
Offer a terse response. 1.29. 